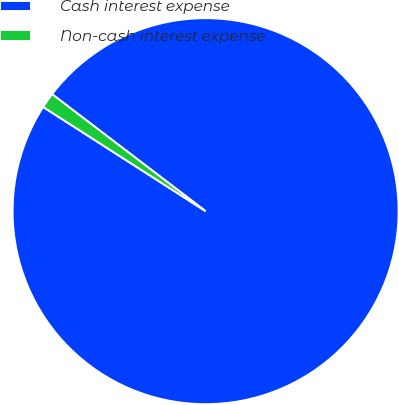<chart> <loc_0><loc_0><loc_500><loc_500><pie_chart><fcel>Cash interest expense<fcel>Non-cash interest expense<nl><fcel>98.71%<fcel>1.29%<nl></chart> 